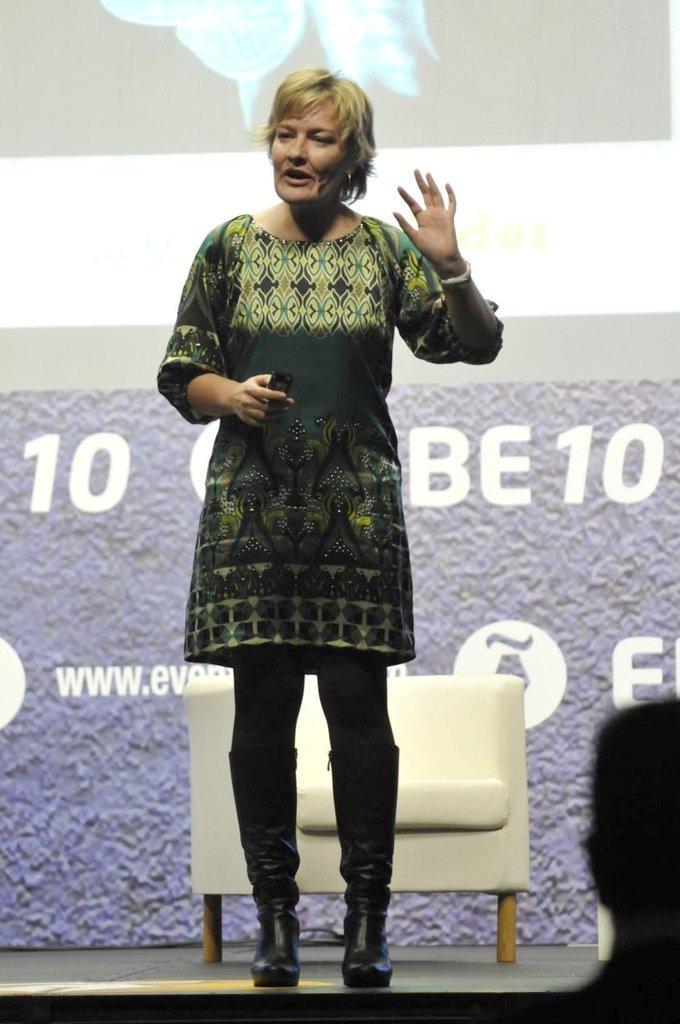Could you give a brief overview of what you see in this image? In the picture we can see a woman standing on the floor and explaining something raising her hand and in the other hand she is holding a mobile phone and behind her we can see a chair which is white in color and behind it we can see a screen with some information on it and in front of her we can see a person sitting. 